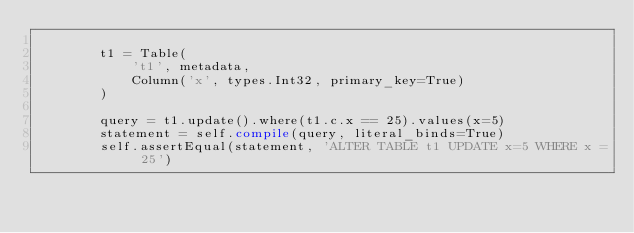<code> <loc_0><loc_0><loc_500><loc_500><_Python_>
        t1 = Table(
            't1', metadata,
            Column('x', types.Int32, primary_key=True)
        )

        query = t1.update().where(t1.c.x == 25).values(x=5)
        statement = self.compile(query, literal_binds=True)
        self.assertEqual(statement, 'ALTER TABLE t1 UPDATE x=5 WHERE x = 25')
</code> 